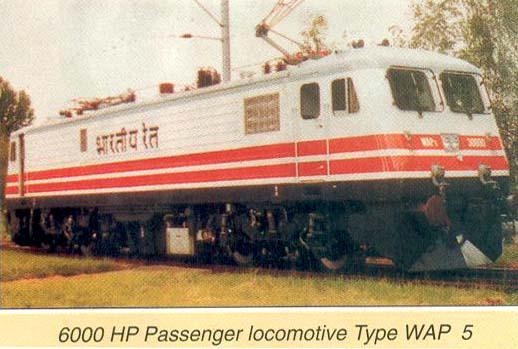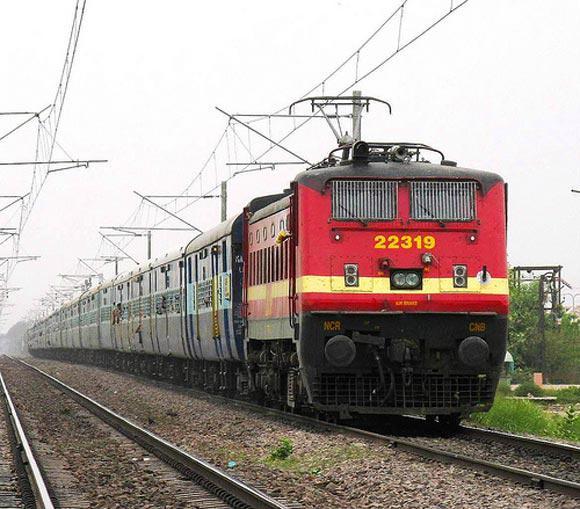The first image is the image on the left, the second image is the image on the right. Assess this claim about the two images: "The engine in the image on the right is white with a red stripe on it.". Correct or not? Answer yes or no. No. The first image is the image on the left, the second image is the image on the right. Assess this claim about the two images: "One train is primarily white with at least one red stripe, and the other train is primarily red with a pale stripe.". Correct or not? Answer yes or no. Yes. 